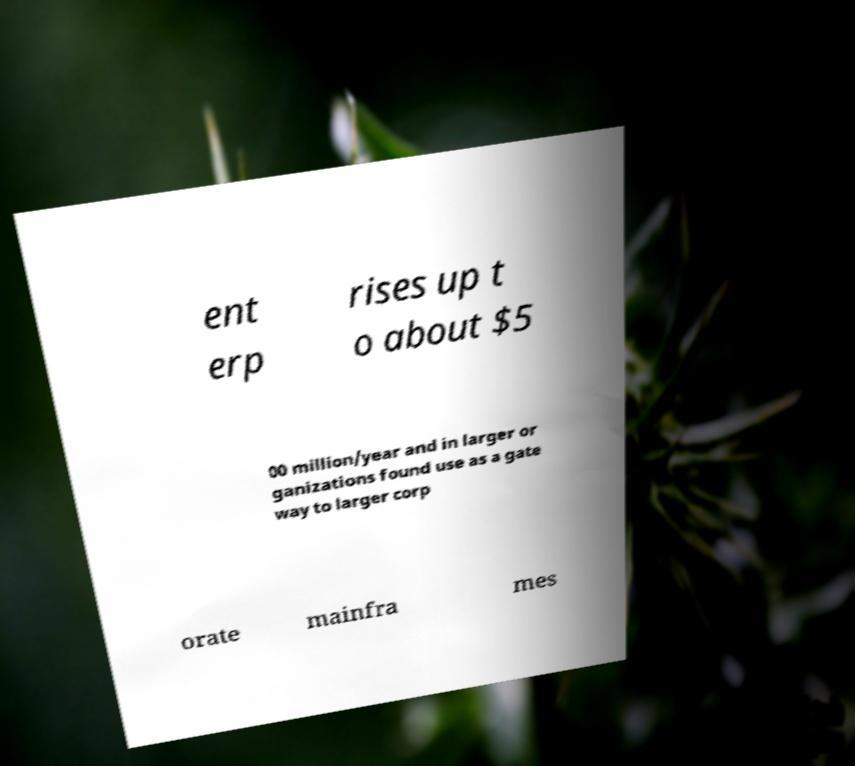I need the written content from this picture converted into text. Can you do that? ent erp rises up t o about $5 00 million/year and in larger or ganizations found use as a gate way to larger corp orate mainfra mes 